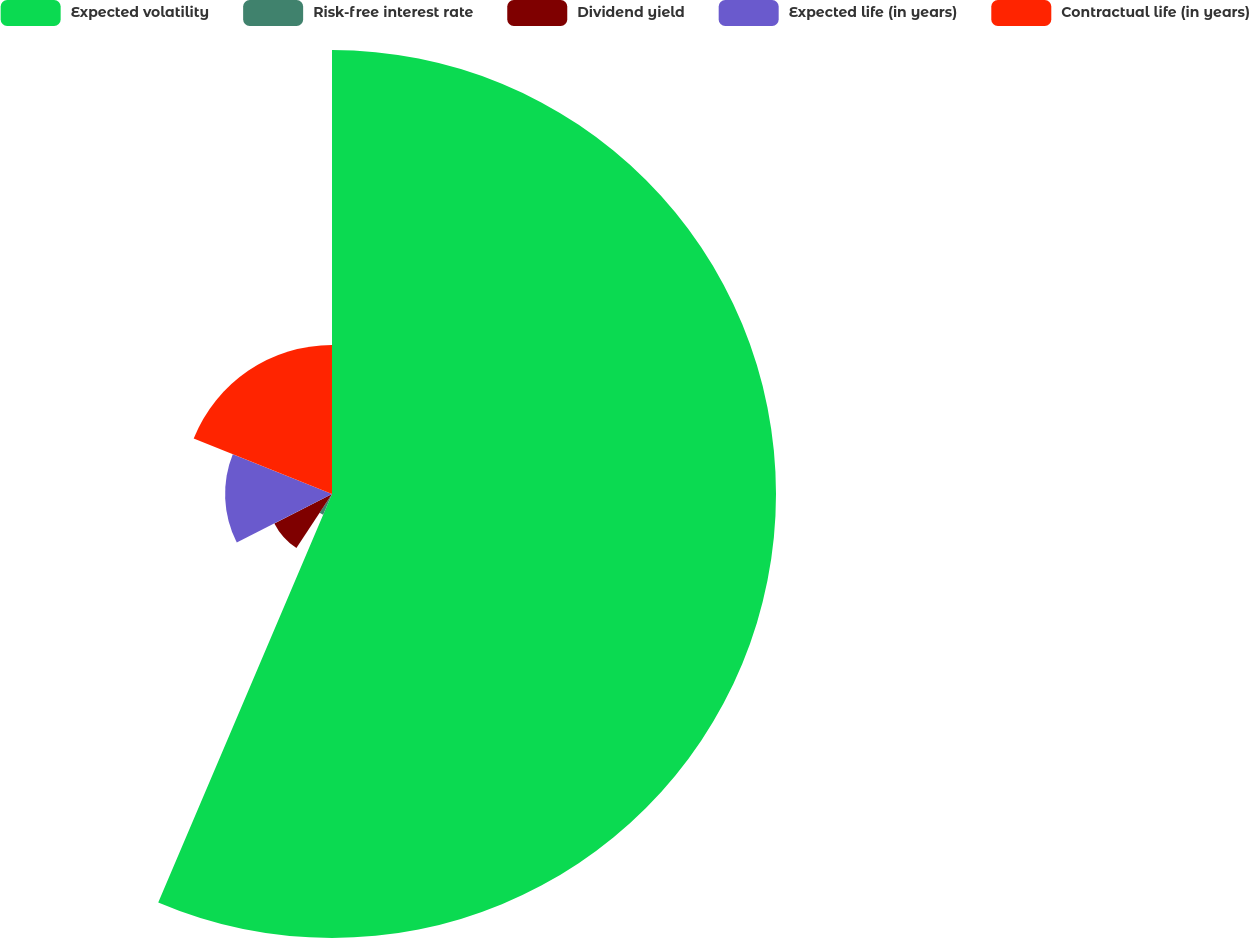<chart> <loc_0><loc_0><loc_500><loc_500><pie_chart><fcel>Expected volatility<fcel>Risk-free interest rate<fcel>Dividend yield<fcel>Expected life (in years)<fcel>Contractual life (in years)<nl><fcel>56.4%<fcel>2.87%<fcel>8.22%<fcel>13.58%<fcel>18.93%<nl></chart> 